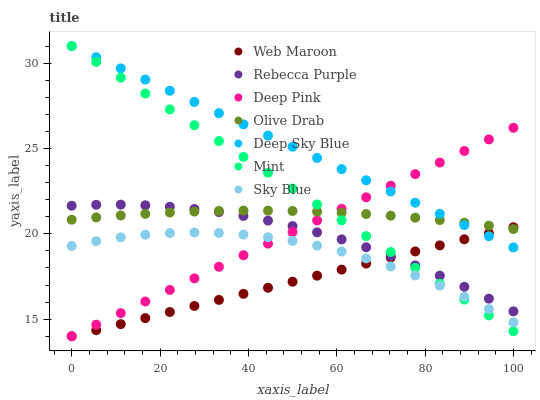Does Web Maroon have the minimum area under the curve?
Answer yes or no. Yes. Does Deep Sky Blue have the maximum area under the curve?
Answer yes or no. Yes. Does Rebecca Purple have the minimum area under the curve?
Answer yes or no. No. Does Rebecca Purple have the maximum area under the curve?
Answer yes or no. No. Is Mint the smoothest?
Answer yes or no. Yes. Is Sky Blue the roughest?
Answer yes or no. Yes. Is Web Maroon the smoothest?
Answer yes or no. No. Is Web Maroon the roughest?
Answer yes or no. No. Does Deep Pink have the lowest value?
Answer yes or no. Yes. Does Rebecca Purple have the lowest value?
Answer yes or no. No. Does Mint have the highest value?
Answer yes or no. Yes. Does Web Maroon have the highest value?
Answer yes or no. No. Is Sky Blue less than Olive Drab?
Answer yes or no. Yes. Is Deep Sky Blue greater than Sky Blue?
Answer yes or no. Yes. Does Deep Sky Blue intersect Web Maroon?
Answer yes or no. Yes. Is Deep Sky Blue less than Web Maroon?
Answer yes or no. No. Is Deep Sky Blue greater than Web Maroon?
Answer yes or no. No. Does Sky Blue intersect Olive Drab?
Answer yes or no. No. 